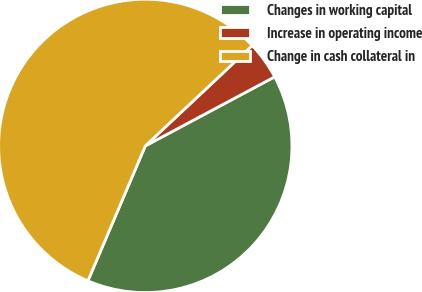Convert chart to OTSL. <chart><loc_0><loc_0><loc_500><loc_500><pie_chart><fcel>Changes in working capital<fcel>Increase in operating income<fcel>Change in cash collateral in<nl><fcel>39.21%<fcel>4.19%<fcel>56.61%<nl></chart> 